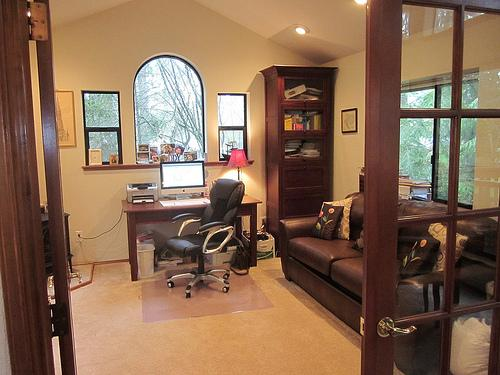What type of accessory is used to protect the carpet in the office area? A vinyl mat is beneath the wheels of the office chair. Identify the color and pattern on the two pillows that are on the couch. Brown with a pink flower pattern. Describe the window in the home office and what can be seen outside it. An arched window frames the trees outside. What is the color and style of the lampshade in the image? It is a red shade on a lamp. What kind of sofa is in the picture, and what is on it? A leather couch with multiple pillows, including ones that are light colored and brown with pink flowers. Mention some features of the office chair in the image. The office chair is black, gray, has wheels, and is situated on a vinyl mat. Describe the location and appearance of the clock in the image. The clock is sitting on the windowsill, with its white face and black hands visible. Where is the trash can in the image and what is it under? The trash can is under the desk. What type of furniture is placed in the corner of the home office and its color? A dark wooden tall bookshelf. Point out an object in the image that is part of the room decor and describe its position. A framed picture hanging on the wall. 